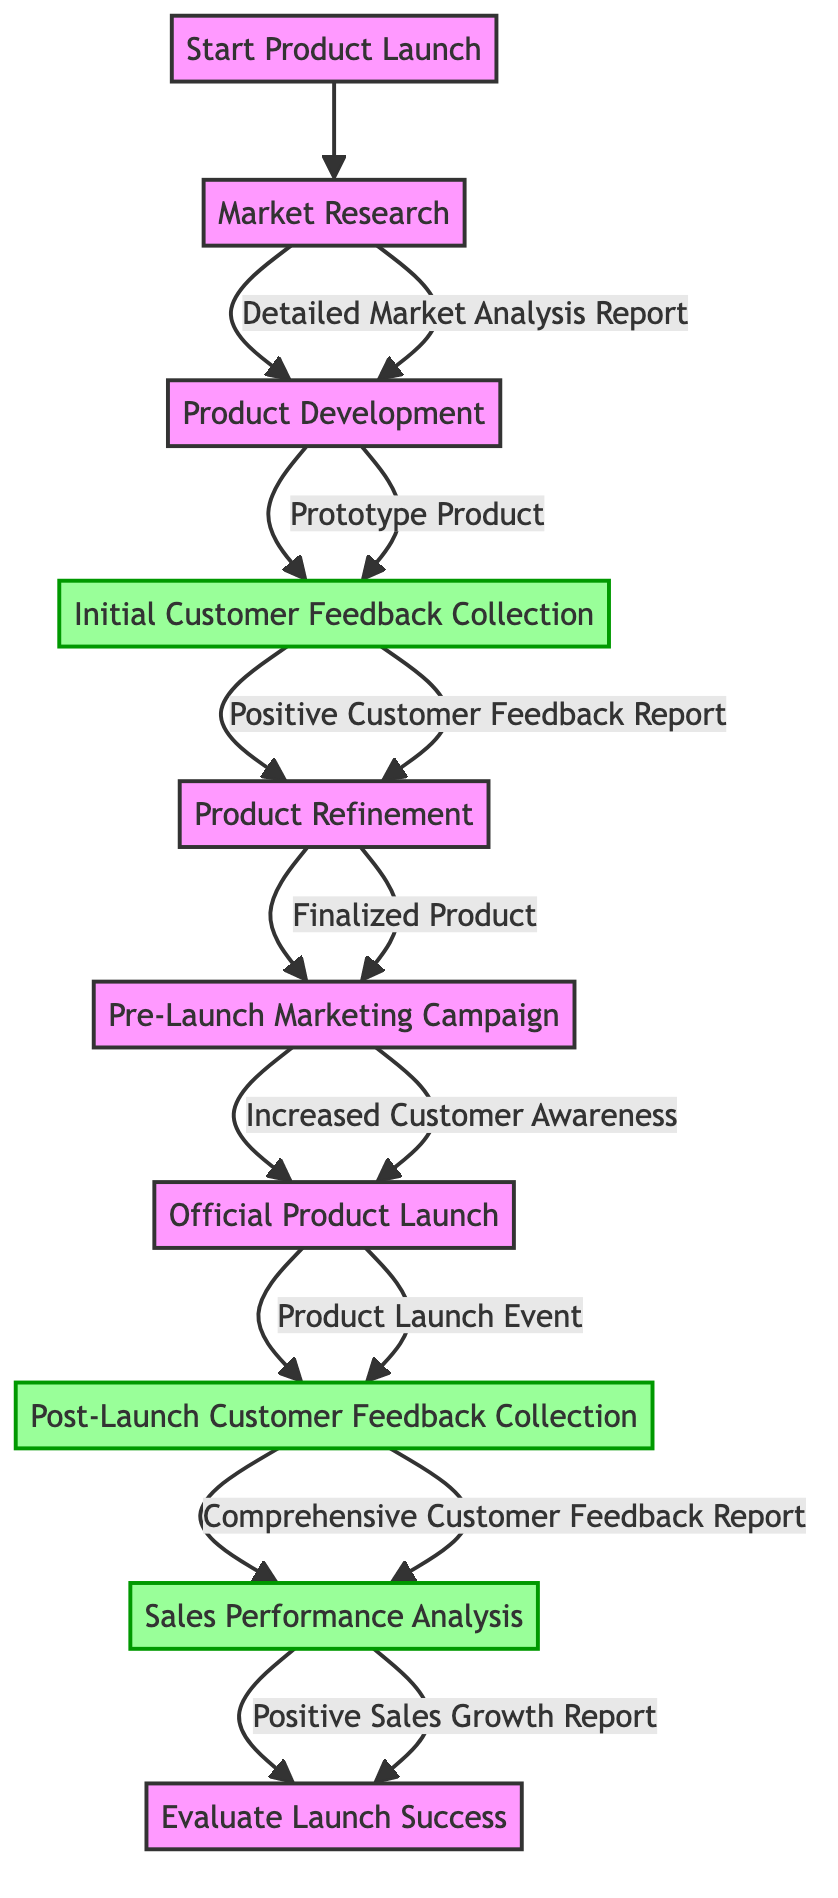What is the first action in the product launch process? The first action is indicated by the starting point of the diagram, which leads directly to 'Market Research'.
Answer: Market Research What is the output of the 'Product Development' action? The output from 'Product Development' is represented by the arrow leading to the next action, indicating it produces a 'Prototype Product'.
Answer: Prototype Product How many actions are there in the product launch process? By counting each action node in the diagram from 'Market Research' to 'Sales Performance Analysis', there are a total of 8 actions.
Answer: 8 Which action follows 'Product Refinement'? From the flow of the diagram, after 'Product Refinement', the next action is 'Pre-Launch Marketing Campaign'.
Answer: Pre-Launch Marketing Campaign What type of feedback is collected after the official product launch? The diagram shows that 'Post-Launch Customer Feedback Collection' follows the launch, which collects 'Comprehensive Customer Feedback Report'.
Answer: Comprehensive Customer Feedback Report What is the relationship between 'Initial Customer Feedback Collection' and 'Product Refinement'? The output from 'Initial Customer Feedback Collection' leads to 'Product Refinement', indicating that customer feedback directly informs the refinement process.
Answer: Positive Customer Feedback Report What do we analyze after the 'Post-Launch Customer Feedback Collection'? The next action after collecting post-launch feedback is 'Sales Performance Analysis', which indicates that sales data is reviewed following feedback collection.
Answer: Sales Performance Analysis What is the final step in the product launch process? The diagram terminates at 'Evaluate Launch Success', which is the last action in the flow.
Answer: Evaluate Launch Success What do the actions 'Initial Customer Feedback Collection' and 'Post-Launch Customer Feedback Collection' have in common? Both actions are focused on gathering customer feedback at different stages, showcasing the importance of consumer insights throughout the process.
Answer: Customer Feedback 